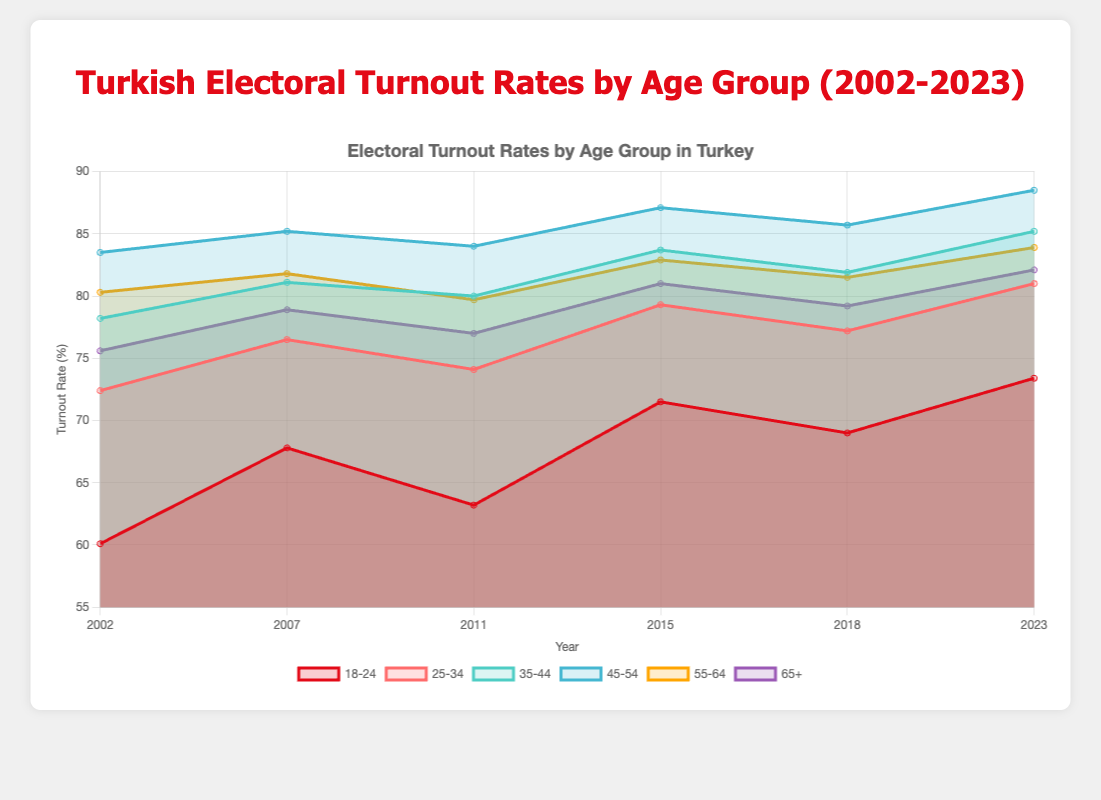What is the title of the chart? The title of the chart is found at the top and it summarizes the content being displayed. By looking at the top of the chart, you see the text that says "Turkish Electoral Turnout Rates by Age Group (2002-2023)".
Answer: Turkish Electoral Turnout Rates by Age Group (2002-2023) How many age groups are represented in the chart? By examining the legend and the labels on the chart, you can count the different age groups depicted. There are six age groups indicated by different colors and labels.
Answer: 6 Which age group had the lowest turnout rate in 2011? Looking at the data points for the year 2011 and identifying the lowest value across all age groups, you can see that the '18-24' age group has the lowest turnout rate at 63.2%.
Answer: 18-24 How has the turnout rate for the age group 45-54 changed between 2002 and 2023? Compare the values of the '45-54' age group at the starting year (2002) and the ending year (2023). In 2002, it was 83.5% and in 2023, it was 88.5%. So, the change is 88.5% - 83.5% = 5%.
Answer: Increased by 5% What was the turnout rate for the age group 25-34 in 2007? Locate the specific data point for the '25-34' age group at the year 2007. The chart shows it as one of the labels on the x-axis and the corresponding value in the legend. The value is 76.5%.
Answer: 76.5% Which year saw the highest turnout rate for the age group 65 and above? Look at the data points for the '65+' age group across all years depicted in the chart and identify the highest value. In 2023, the turnout rate was the highest at 82.1%.
Answer: 2023 What is the overall trend in electoral turnout rates for the 18-24 age group from 2002 to 2023? Observe the data points for the '18-24' age group from 2002 to 2023 and describe whether the values generally increase, decrease, or remain the same. The trend shows an increase from 60.1% in 2002 to 73.4% in 2023, indicating an upward trend.
Answer: Increasing In which year did the age group 55-64 experience a drop in turnout rate compared to the previous year? Examine the chart to find the year where the turnout rate for the '55-64' age group is lower compared to the previous year. Between 2011 (79.7%) and 2007 (81.8%), there is a decrease of 2.1%.
Answer: 2011 What's the average turnout rate for the age group 35-44 over the 21-year span shown in the chart? Calculate the average by summing up the turnout rates for the '35-44' age group over all the years and then dividing by the number of years. The data points are 78.2, 81.1, 80.0, 83.7, 81.9, and 85.2. The sum is 490.1 and the average is 490.1/6 = 81.68%.
Answer: 81.68% 